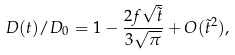Convert formula to latex. <formula><loc_0><loc_0><loc_500><loc_500>D ( t ) / D _ { 0 } = 1 - \frac { 2 f \sqrt { \tilde { t } } } { 3 \sqrt { \pi } } + O ( \tilde { t } ^ { 2 } ) ,</formula> 